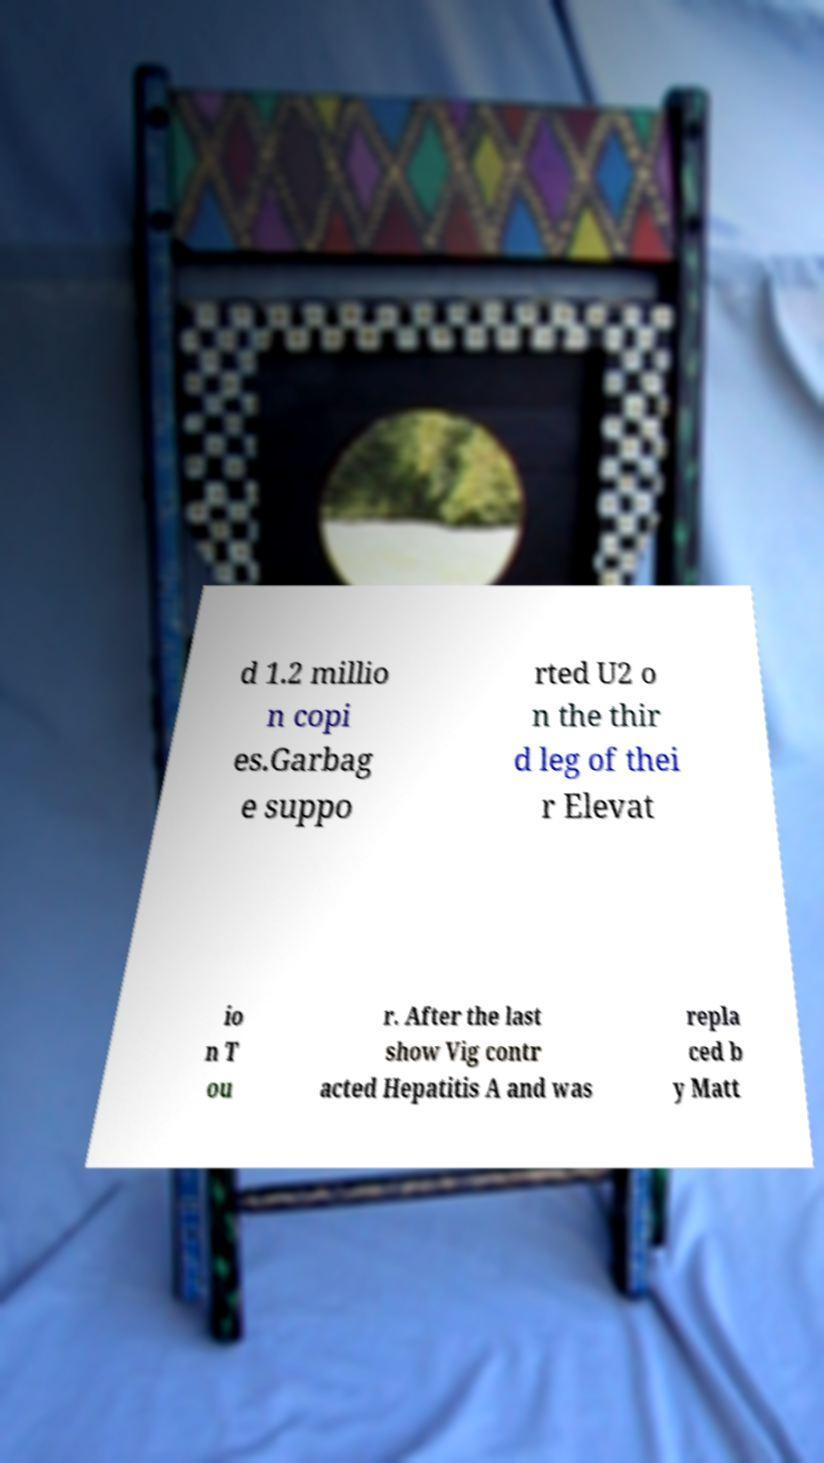Please read and relay the text visible in this image. What does it say? d 1.2 millio n copi es.Garbag e suppo rted U2 o n the thir d leg of thei r Elevat io n T ou r. After the last show Vig contr acted Hepatitis A and was repla ced b y Matt 